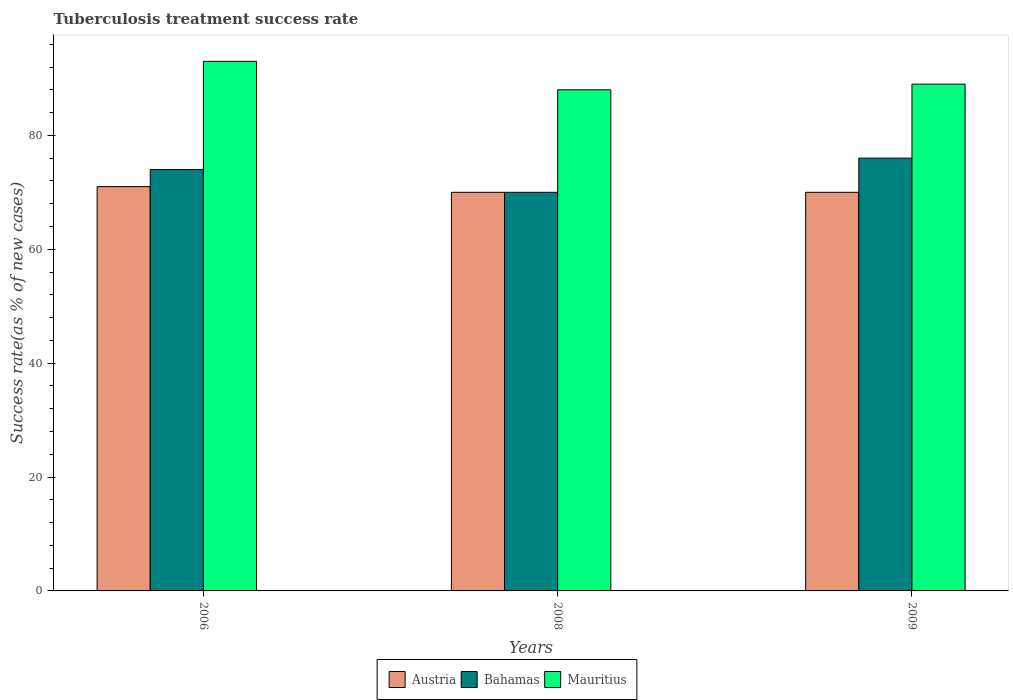How many groups of bars are there?
Provide a short and direct response. 3. How many bars are there on the 2nd tick from the left?
Provide a succinct answer. 3. What is the label of the 3rd group of bars from the left?
Make the answer very short. 2009. In how many cases, is the number of bars for a given year not equal to the number of legend labels?
Keep it short and to the point. 0. What is the tuberculosis treatment success rate in Mauritius in 2009?
Your answer should be compact. 89. Across all years, what is the maximum tuberculosis treatment success rate in Mauritius?
Your answer should be compact. 93. What is the total tuberculosis treatment success rate in Mauritius in the graph?
Offer a very short reply. 270. What is the difference between the tuberculosis treatment success rate in Mauritius in 2008 and the tuberculosis treatment success rate in Bahamas in 2009?
Provide a short and direct response. 12. What is the average tuberculosis treatment success rate in Austria per year?
Your answer should be compact. 70.33. In how many years, is the tuberculosis treatment success rate in Mauritius greater than 48 %?
Give a very brief answer. 3. What is the ratio of the tuberculosis treatment success rate in Bahamas in 2006 to that in 2009?
Your answer should be very brief. 0.97. What is the difference between the highest and the second highest tuberculosis treatment success rate in Bahamas?
Your answer should be compact. 2. In how many years, is the tuberculosis treatment success rate in Mauritius greater than the average tuberculosis treatment success rate in Mauritius taken over all years?
Offer a very short reply. 1. What does the 3rd bar from the left in 2006 represents?
Provide a short and direct response. Mauritius. What does the 2nd bar from the right in 2009 represents?
Give a very brief answer. Bahamas. Is it the case that in every year, the sum of the tuberculosis treatment success rate in Bahamas and tuberculosis treatment success rate in Austria is greater than the tuberculosis treatment success rate in Mauritius?
Provide a short and direct response. Yes. What is the difference between two consecutive major ticks on the Y-axis?
Offer a very short reply. 20. Does the graph contain any zero values?
Offer a very short reply. No. Does the graph contain grids?
Provide a short and direct response. No. Where does the legend appear in the graph?
Your answer should be compact. Bottom center. How many legend labels are there?
Offer a terse response. 3. What is the title of the graph?
Ensure brevity in your answer.  Tuberculosis treatment success rate. Does "Benin" appear as one of the legend labels in the graph?
Provide a short and direct response. No. What is the label or title of the Y-axis?
Offer a very short reply. Success rate(as % of new cases). What is the Success rate(as % of new cases) in Bahamas in 2006?
Offer a very short reply. 74. What is the Success rate(as % of new cases) in Mauritius in 2006?
Offer a very short reply. 93. What is the Success rate(as % of new cases) in Austria in 2008?
Your response must be concise. 70. What is the Success rate(as % of new cases) in Mauritius in 2008?
Your answer should be very brief. 88. What is the Success rate(as % of new cases) of Austria in 2009?
Keep it short and to the point. 70. What is the Success rate(as % of new cases) in Mauritius in 2009?
Your answer should be compact. 89. Across all years, what is the maximum Success rate(as % of new cases) in Austria?
Ensure brevity in your answer.  71. Across all years, what is the maximum Success rate(as % of new cases) of Bahamas?
Make the answer very short. 76. Across all years, what is the maximum Success rate(as % of new cases) of Mauritius?
Provide a short and direct response. 93. Across all years, what is the minimum Success rate(as % of new cases) of Austria?
Give a very brief answer. 70. Across all years, what is the minimum Success rate(as % of new cases) of Bahamas?
Your response must be concise. 70. Across all years, what is the minimum Success rate(as % of new cases) of Mauritius?
Give a very brief answer. 88. What is the total Success rate(as % of new cases) in Austria in the graph?
Make the answer very short. 211. What is the total Success rate(as % of new cases) of Bahamas in the graph?
Offer a very short reply. 220. What is the total Success rate(as % of new cases) of Mauritius in the graph?
Give a very brief answer. 270. What is the difference between the Success rate(as % of new cases) of Bahamas in 2006 and that in 2008?
Your response must be concise. 4. What is the difference between the Success rate(as % of new cases) of Mauritius in 2006 and that in 2008?
Offer a very short reply. 5. What is the difference between the Success rate(as % of new cases) in Bahamas in 2006 and that in 2009?
Your answer should be compact. -2. What is the difference between the Success rate(as % of new cases) of Mauritius in 2006 and that in 2009?
Provide a short and direct response. 4. What is the difference between the Success rate(as % of new cases) in Bahamas in 2008 and that in 2009?
Your answer should be compact. -6. What is the difference between the Success rate(as % of new cases) in Mauritius in 2008 and that in 2009?
Provide a short and direct response. -1. What is the difference between the Success rate(as % of new cases) of Austria in 2006 and the Success rate(as % of new cases) of Bahamas in 2008?
Give a very brief answer. 1. What is the difference between the Success rate(as % of new cases) in Austria in 2006 and the Success rate(as % of new cases) in Bahamas in 2009?
Your response must be concise. -5. What is the difference between the Success rate(as % of new cases) of Austria in 2008 and the Success rate(as % of new cases) of Bahamas in 2009?
Provide a short and direct response. -6. What is the difference between the Success rate(as % of new cases) of Austria in 2008 and the Success rate(as % of new cases) of Mauritius in 2009?
Give a very brief answer. -19. What is the average Success rate(as % of new cases) of Austria per year?
Provide a succinct answer. 70.33. What is the average Success rate(as % of new cases) in Bahamas per year?
Ensure brevity in your answer.  73.33. What is the average Success rate(as % of new cases) of Mauritius per year?
Keep it short and to the point. 90. In the year 2006, what is the difference between the Success rate(as % of new cases) in Bahamas and Success rate(as % of new cases) in Mauritius?
Keep it short and to the point. -19. In the year 2008, what is the difference between the Success rate(as % of new cases) of Austria and Success rate(as % of new cases) of Mauritius?
Your answer should be compact. -18. In the year 2008, what is the difference between the Success rate(as % of new cases) of Bahamas and Success rate(as % of new cases) of Mauritius?
Your answer should be compact. -18. In the year 2009, what is the difference between the Success rate(as % of new cases) in Austria and Success rate(as % of new cases) in Bahamas?
Provide a succinct answer. -6. What is the ratio of the Success rate(as % of new cases) of Austria in 2006 to that in 2008?
Make the answer very short. 1.01. What is the ratio of the Success rate(as % of new cases) of Bahamas in 2006 to that in 2008?
Your answer should be very brief. 1.06. What is the ratio of the Success rate(as % of new cases) of Mauritius in 2006 to that in 2008?
Ensure brevity in your answer.  1.06. What is the ratio of the Success rate(as % of new cases) in Austria in 2006 to that in 2009?
Offer a very short reply. 1.01. What is the ratio of the Success rate(as % of new cases) of Bahamas in 2006 to that in 2009?
Keep it short and to the point. 0.97. What is the ratio of the Success rate(as % of new cases) in Mauritius in 2006 to that in 2009?
Offer a very short reply. 1.04. What is the ratio of the Success rate(as % of new cases) of Austria in 2008 to that in 2009?
Ensure brevity in your answer.  1. What is the ratio of the Success rate(as % of new cases) of Bahamas in 2008 to that in 2009?
Give a very brief answer. 0.92. What is the difference between the highest and the second highest Success rate(as % of new cases) of Austria?
Give a very brief answer. 1. What is the difference between the highest and the second highest Success rate(as % of new cases) of Mauritius?
Make the answer very short. 4. What is the difference between the highest and the lowest Success rate(as % of new cases) in Austria?
Your answer should be very brief. 1. What is the difference between the highest and the lowest Success rate(as % of new cases) in Bahamas?
Provide a succinct answer. 6. What is the difference between the highest and the lowest Success rate(as % of new cases) in Mauritius?
Your answer should be very brief. 5. 